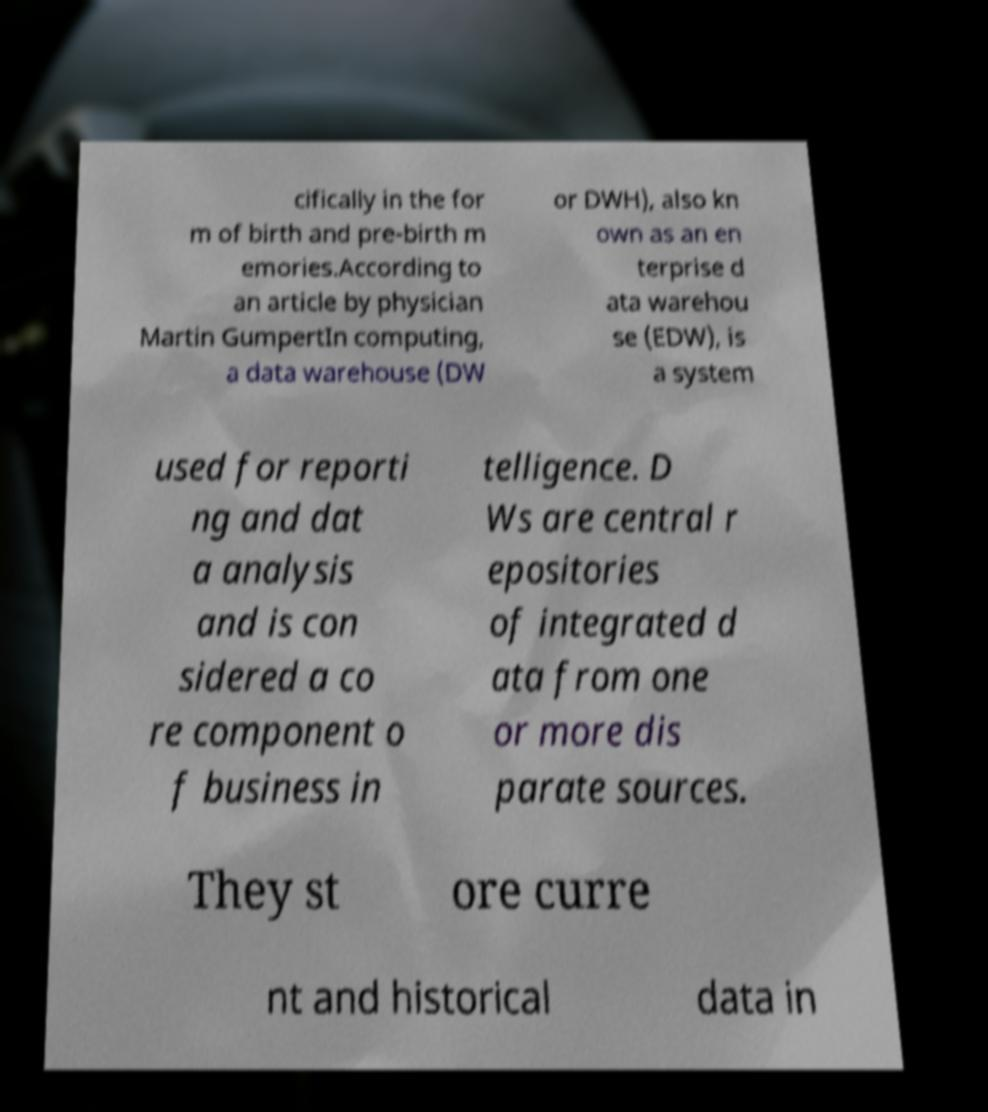Please read and relay the text visible in this image. What does it say? cifically in the for m of birth and pre-birth m emories.According to an article by physician Martin GumpertIn computing, a data warehouse (DW or DWH), also kn own as an en terprise d ata warehou se (EDW), is a system used for reporti ng and dat a analysis and is con sidered a co re component o f business in telligence. D Ws are central r epositories of integrated d ata from one or more dis parate sources. They st ore curre nt and historical data in 